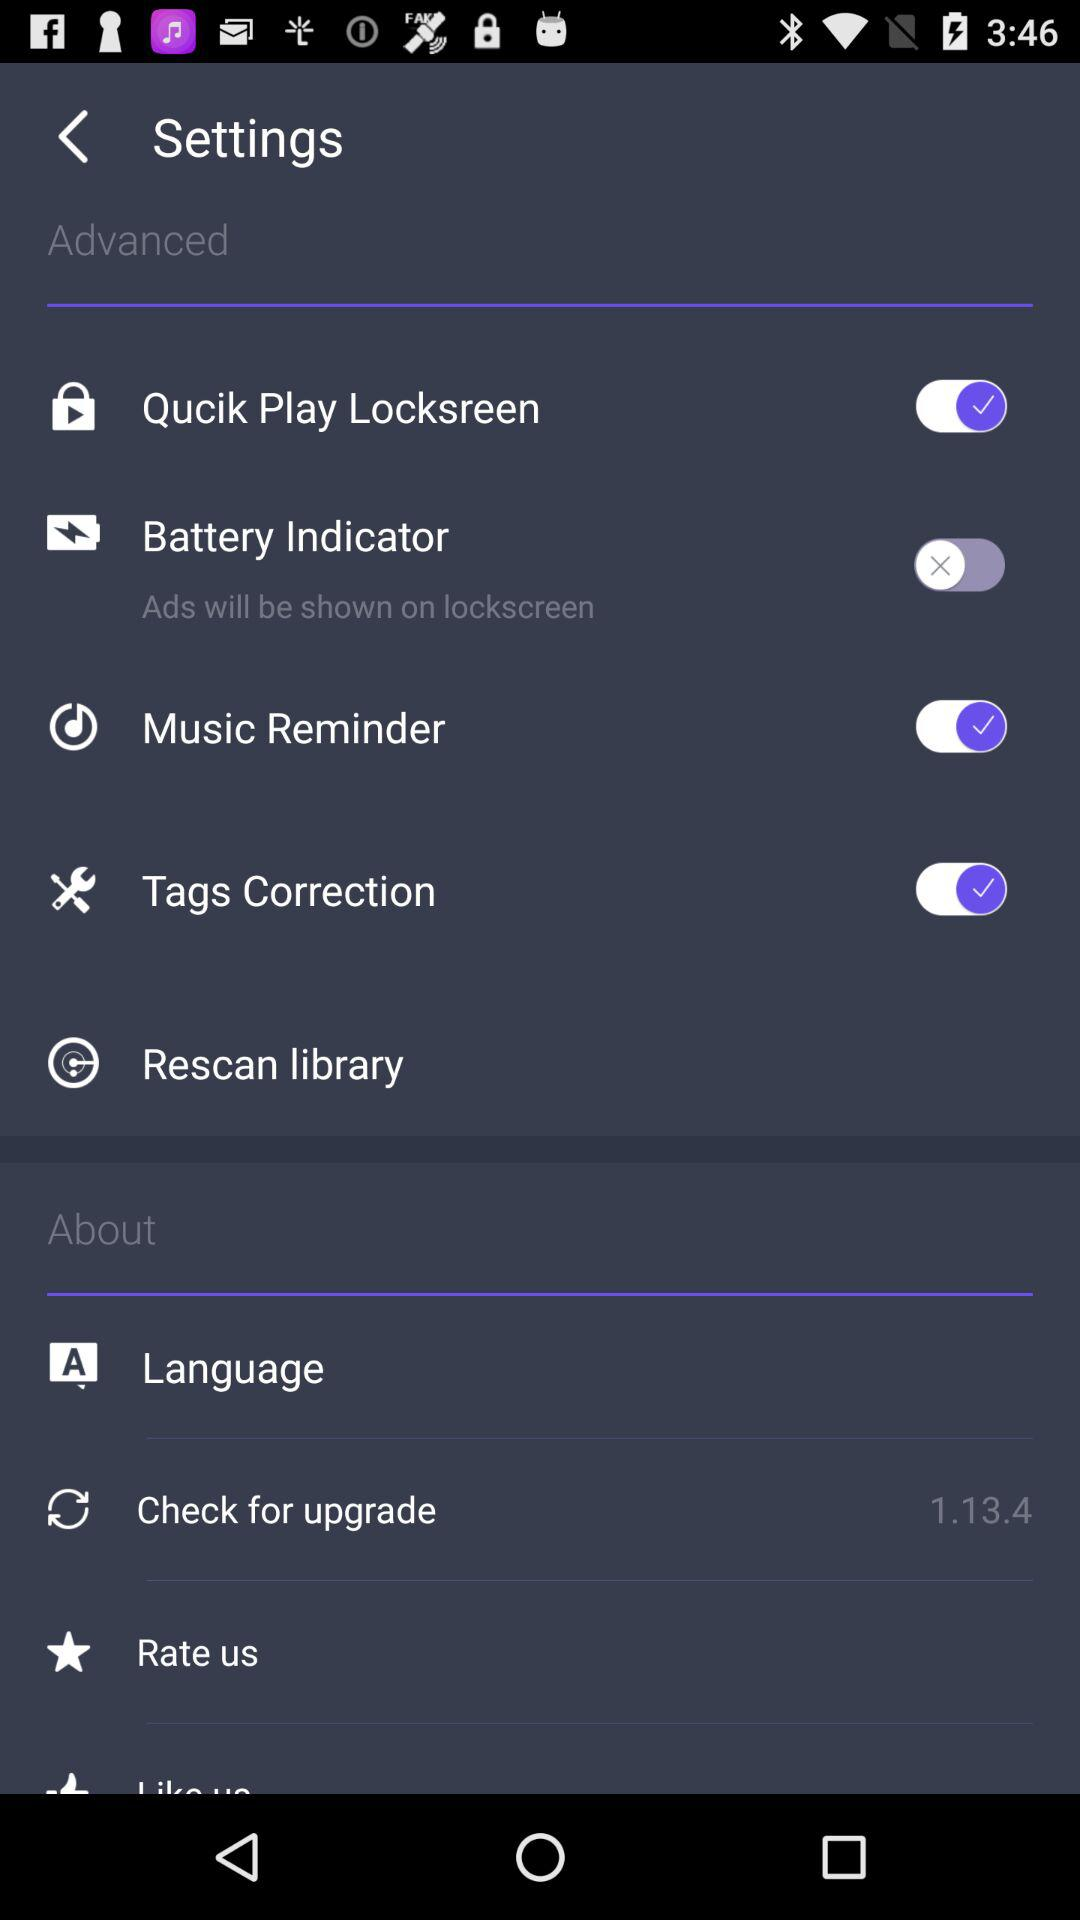What's the status of Quick Play Locksreen? The status of Quick Play Locksreen is on. 